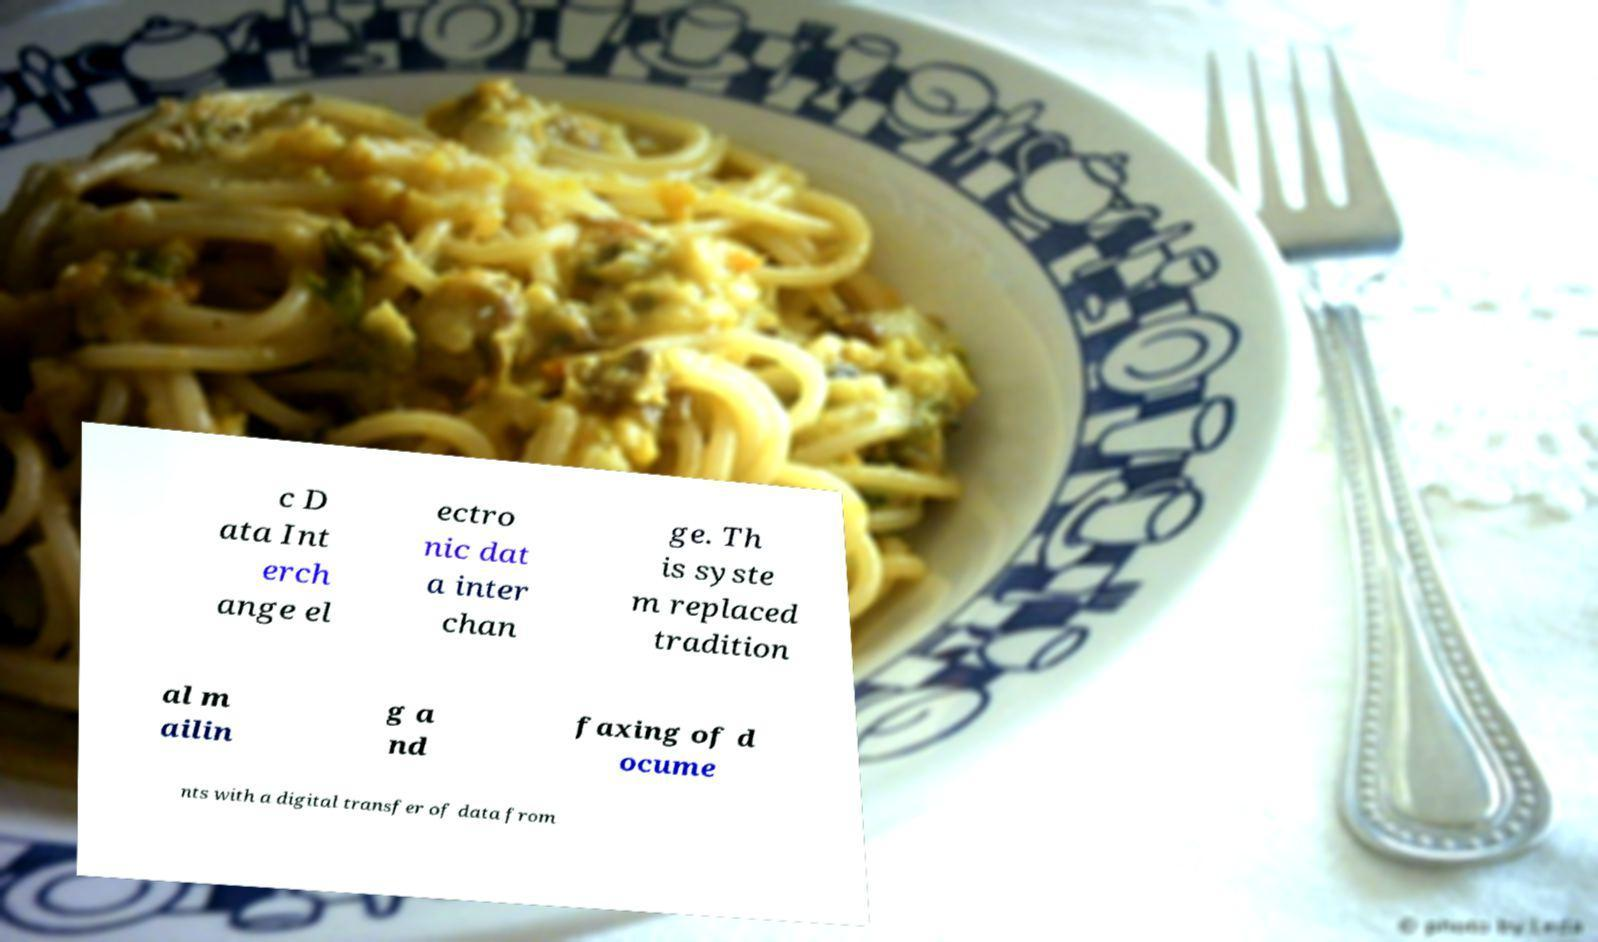Please read and relay the text visible in this image. What does it say? c D ata Int erch ange el ectro nic dat a inter chan ge. Th is syste m replaced tradition al m ailin g a nd faxing of d ocume nts with a digital transfer of data from 